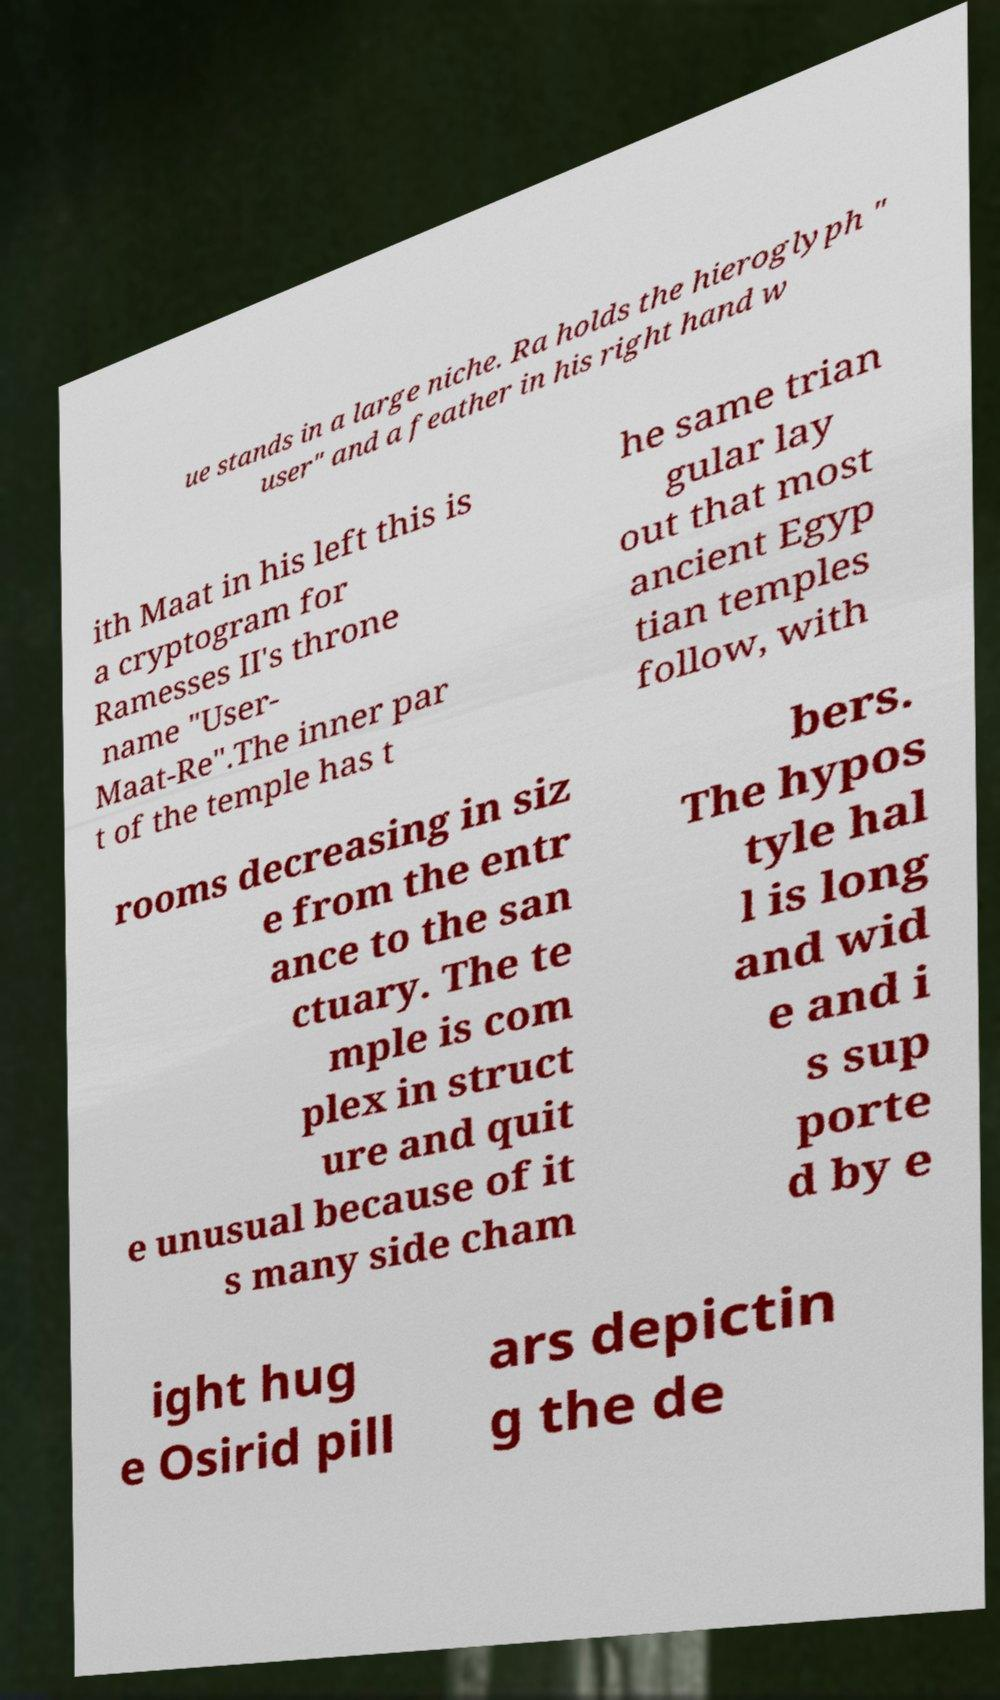What messages or text are displayed in this image? I need them in a readable, typed format. ue stands in a large niche. Ra holds the hieroglyph " user" and a feather in his right hand w ith Maat in his left this is a cryptogram for Ramesses II's throne name "User- Maat-Re".The inner par t of the temple has t he same trian gular lay out that most ancient Egyp tian temples follow, with rooms decreasing in siz e from the entr ance to the san ctuary. The te mple is com plex in struct ure and quit e unusual because of it s many side cham bers. The hypos tyle hal l is long and wid e and i s sup porte d by e ight hug e Osirid pill ars depictin g the de 